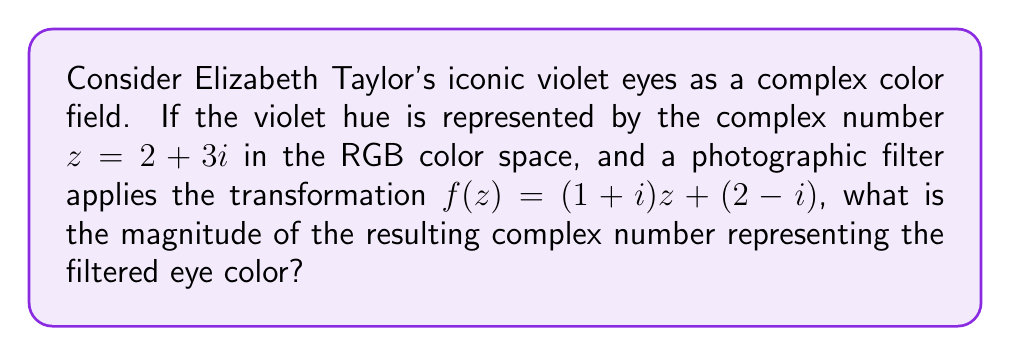What is the answer to this math problem? Let's approach this step-by-step:

1) We start with the complex number $z = 2 + 3i$ representing the violet hue.

2) The filter applies the transformation $f(z) = (1+i)z + (2-i)$.

3) Let's calculate $f(z)$:
   $f(z) = (1+i)(2+3i) + (2-i)$

4) Expanding the first term:
   $(1+i)(2+3i) = 2 + 3i + 2i + 3i^2 = 2 + 3i + 2i - 3 = -1 + 5i$

5) Now, we can add the second term:
   $f(z) = (-1 + 5i) + (2-i) = 1 + 4i$

6) The resulting complex number is $1 + 4i$.

7) To find the magnitude of this complex number, we use the formula:
   $|a + bi| = \sqrt{a^2 + b^2}$

8) Substituting our values:
   $|1 + 4i| = \sqrt{1^2 + 4^2} = \sqrt{1 + 16} = \sqrt{17}$

Therefore, the magnitude of the resulting complex number is $\sqrt{17}$.
Answer: $\sqrt{17}$ 